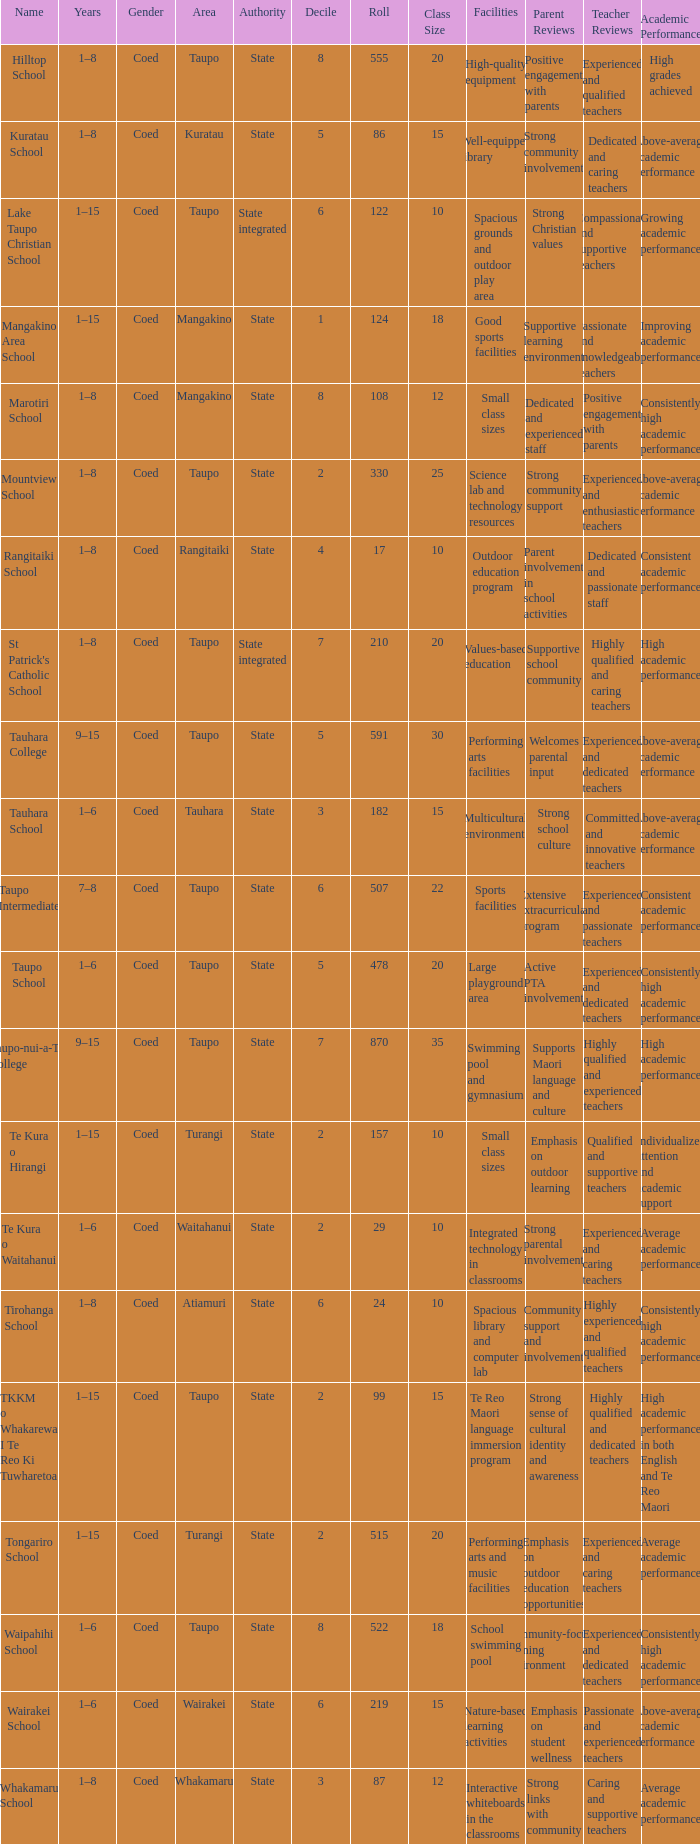Give me the full table as a dictionary. {'header': ['Name', 'Years', 'Gender', 'Area', 'Authority', 'Decile', 'Roll', 'Class Size', 'Facilities', 'Parent Reviews', 'Teacher Reviews', 'Academic Performance'], 'rows': [['Hilltop School', '1–8', 'Coed', 'Taupo', 'State', '8', '555', '20', 'High-quality equipment', 'Positive engagement with parents', 'Experienced and qualified teachers', 'High grades achieved'], ['Kuratau School', '1–8', 'Coed', 'Kuratau', 'State', '5', '86', '15', 'Well-equipped library', 'Strong community involvement', 'Dedicated and caring teachers', 'Above-average academic performance'], ['Lake Taupo Christian School', '1–15', 'Coed', 'Taupo', 'State integrated', '6', '122', '10', 'Spacious grounds and outdoor play area', 'Strong Christian values', 'Compassionate and supportive teachers', 'Growing academic performance'], ['Mangakino Area School', '1–15', 'Coed', 'Mangakino', 'State', '1', '124', '18', 'Good sports facilities', 'Supportive learning environment', 'Passionate and knowledgeable teachers', 'Improving academic performance'], ['Marotiri School', '1–8', 'Coed', 'Mangakino', 'State', '8', '108', '12', 'Small class sizes', 'Dedicated and experienced staff', 'Positive engagement with parents', 'Consistently high academic performance'], ['Mountview School', '1–8', 'Coed', 'Taupo', 'State', '2', '330', '25', 'Science lab and technology resources', 'Strong community support', 'Experienced and enthusiastic teachers', 'Above-average academic performance'], ['Rangitaiki School', '1–8', 'Coed', 'Rangitaiki', 'State', '4', '17', '10', 'Outdoor education program', 'Parent involvement in school activities', 'Dedicated and passionate staff', 'Consistent academic performance'], ["St Patrick's Catholic School", '1–8', 'Coed', 'Taupo', 'State integrated', '7', '210', '20', 'Values-based education', 'Supportive school community', 'Highly qualified and caring teachers', 'High academic performance'], ['Tauhara College', '9–15', 'Coed', 'Taupo', 'State', '5', '591', '30', 'Performing arts facilities', 'Welcomes parental input', 'Experienced and dedicated teachers', 'Above-average academic performance'], ['Tauhara School', '1–6', 'Coed', 'Tauhara', 'State', '3', '182', '15', 'Multicultural environment', 'Strong school culture', 'Committed and innovative teachers', 'Above-average academic performance'], ['Taupo Intermediate', '7–8', 'Coed', 'Taupo', 'State', '6', '507', '22', 'Sports facilities', 'Extensive extracurricular program', 'Experienced and passionate teachers', 'Consistent academic performance'], ['Taupo School', '1–6', 'Coed', 'Taupo', 'State', '5', '478', '20', 'Large playground area', 'Active PTA involvement', 'Experienced and dedicated teachers', 'Consistently high academic performance'], ['Taupo-nui-a-Tia College', '9–15', 'Coed', 'Taupo', 'State', '7', '870', '35', 'Swimming pool and gymnasium', 'Supports Maori language and culture', 'Highly qualified and experienced teachers', 'High academic performance'], ['Te Kura o Hirangi', '1–15', 'Coed', 'Turangi', 'State', '2', '157', '10', 'Small class sizes', 'Emphasis on outdoor learning', 'Qualified and supportive teachers', 'Individualized attention and academic support'], ['Te Kura o Waitahanui', '1–6', 'Coed', 'Waitahanui', 'State', '2', '29', '10', 'Integrated technology in classrooms', 'Strong parental involvement', 'Experienced and caring teachers', 'Average academic performance'], ['Tirohanga School', '1–8', 'Coed', 'Atiamuri', 'State', '6', '24', '10', 'Spacious library and computer lab', 'Community support and involvement', 'Highly experienced and qualified teachers', 'Consistently high academic performance'], ['TKKM o Whakarewa I Te Reo Ki Tuwharetoa', '1–15', 'Coed', 'Taupo', 'State', '2', '99', '15', 'Te Reo Maori language immersion program', 'Strong sense of cultural identity and awareness', 'Highly qualified and dedicated teachers', 'High academic performance in both English and Te Reo Maori'], ['Tongariro School', '1–15', 'Coed', 'Turangi', 'State', '2', '515', '20', 'Performing arts and music facilities', 'Emphasis on outdoor education opportunities', 'Experienced and caring teachers', 'Average academic performance'], ['Waipahihi School', '1–6', 'Coed', 'Taupo', 'State', '8', '522', '18', 'School swimming pool', 'Community-focused learning environment', 'Experienced and dedicated teachers', 'Consistently high academic performance'], ['Wairakei School', '1–6', 'Coed', 'Wairakei', 'State', '6', '219', '15', 'Nature-based learning activities', 'Emphasis on student wellness', 'Passionate and experienced teachers', 'Above-average academic performance'], ['Whakamaru School', '1–8', 'Coed', 'Whakamaru', 'State', '3', '87', '12', 'Interactive whiteboards in the classrooms', 'Strong links with community', 'Caring and supportive teachers', 'Average academic performance']]} Where is the school with state authority that has a roll of more than 157 students? Taupo, Taupo, Taupo, Tauhara, Taupo, Taupo, Taupo, Turangi, Taupo, Wairakei. 